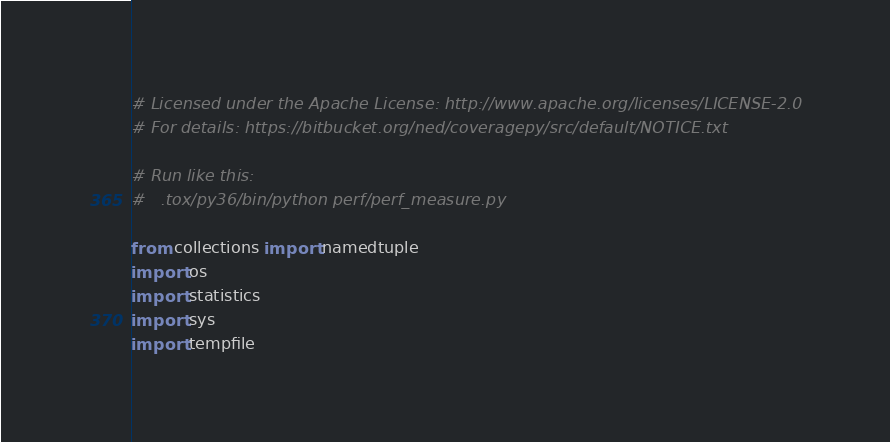<code> <loc_0><loc_0><loc_500><loc_500><_Python_># Licensed under the Apache License: http://www.apache.org/licenses/LICENSE-2.0
# For details: https://bitbucket.org/ned/coveragepy/src/default/NOTICE.txt

# Run like this:
#   .tox/py36/bin/python perf/perf_measure.py

from collections import namedtuple
import os
import statistics
import sys
import tempfile</code> 